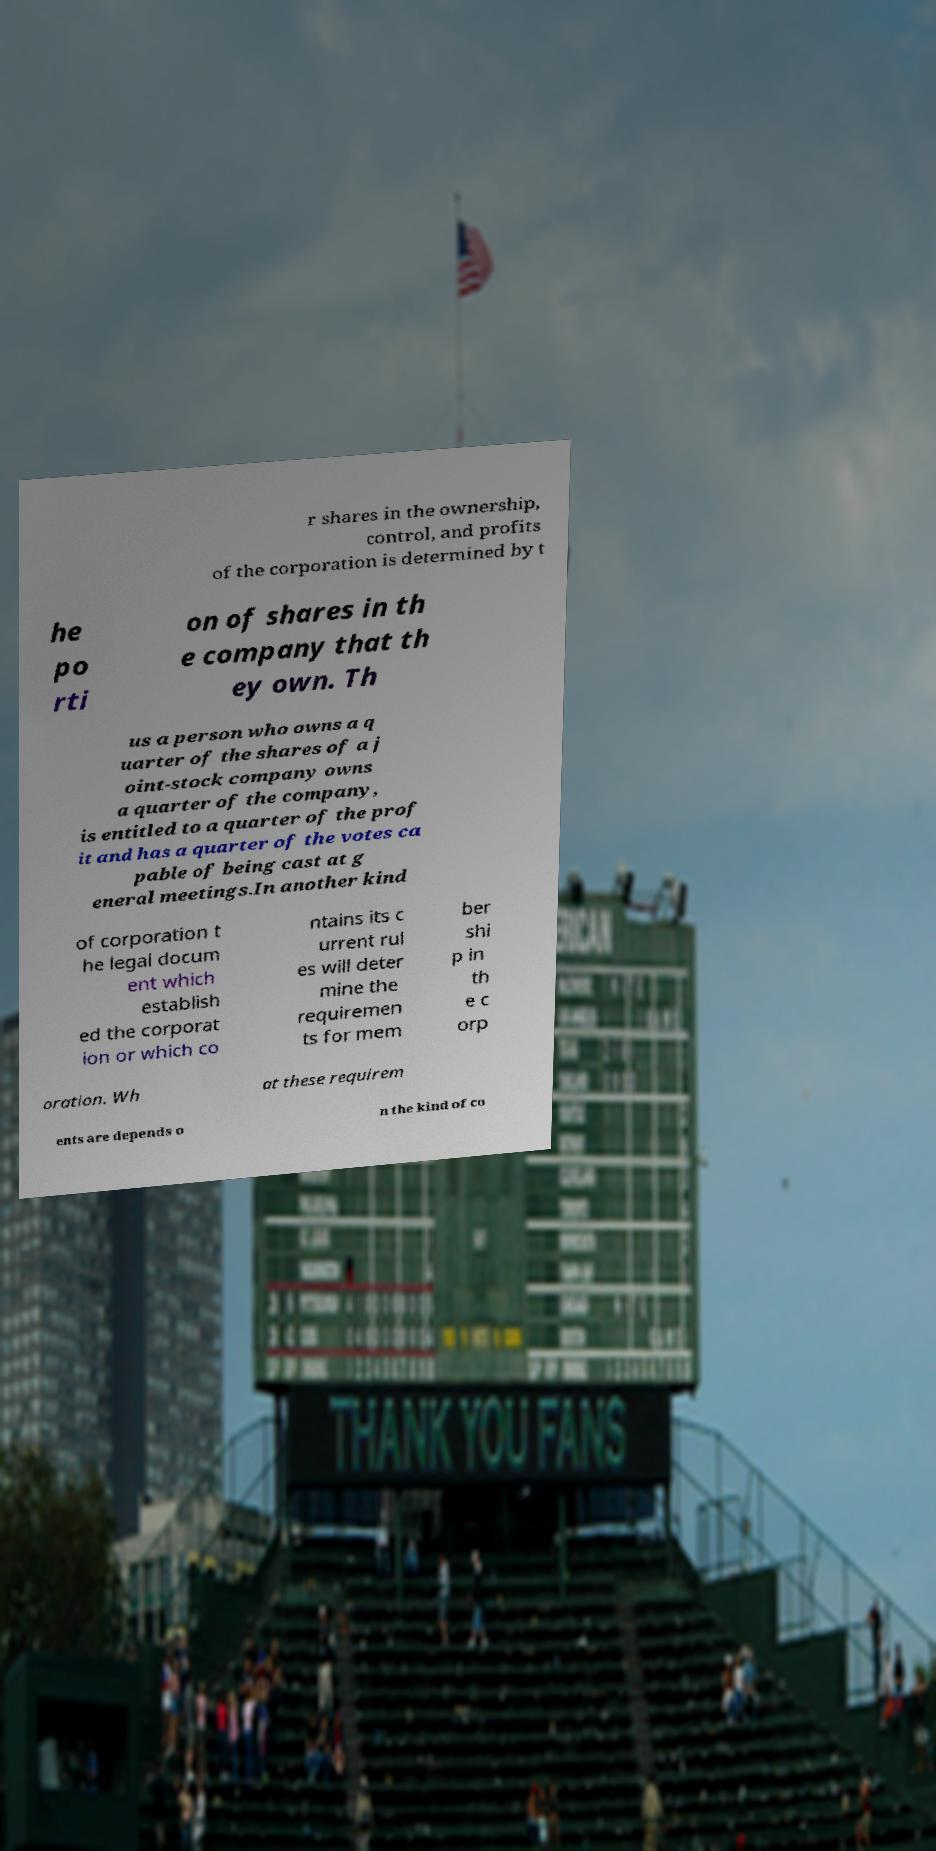Can you read and provide the text displayed in the image?This photo seems to have some interesting text. Can you extract and type it out for me? r shares in the ownership, control, and profits of the corporation is determined by t he po rti on of shares in th e company that th ey own. Th us a person who owns a q uarter of the shares of a j oint-stock company owns a quarter of the company, is entitled to a quarter of the prof it and has a quarter of the votes ca pable of being cast at g eneral meetings.In another kind of corporation t he legal docum ent which establish ed the corporat ion or which co ntains its c urrent rul es will deter mine the requiremen ts for mem ber shi p in th e c orp oration. Wh at these requirem ents are depends o n the kind of co 